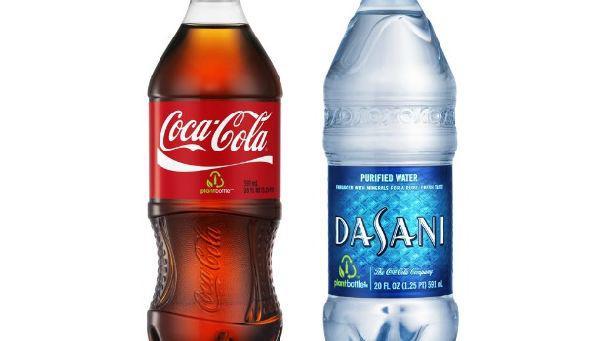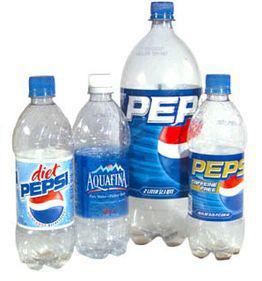The first image is the image on the left, the second image is the image on the right. Evaluate the accuracy of this statement regarding the images: "There are at least seven bottles in total.". Is it true? Answer yes or no. No. 